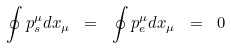<formula> <loc_0><loc_0><loc_500><loc_500>\oint { p ^ { \mu } _ { s } } d x _ { \mu } \ = \ \oint { p ^ { \mu } _ { e } } d x _ { \mu } \ = \ 0</formula> 